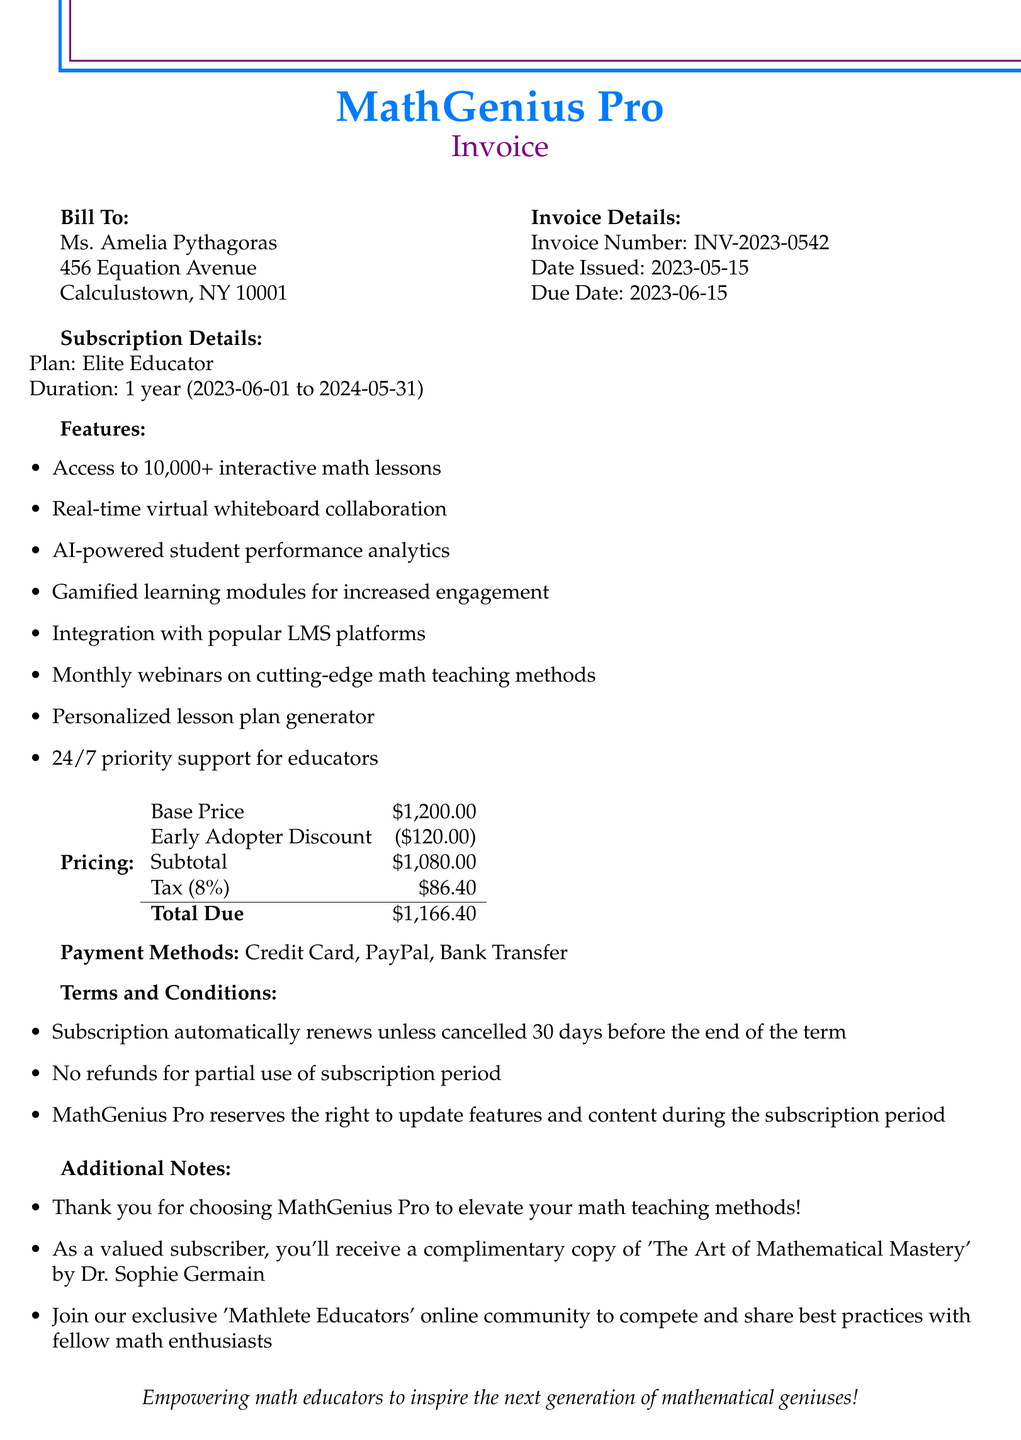What is the invoice number? The invoice number is a unique identifier for the transaction, found in the document.
Answer: INV-2023-0542 What is the due date of the invoice? The due date indicates when the payment must be made, as stated in the document.
Answer: 2023-06-15 What is the annual cost after the discount? The annual cost is listed in the pricing section after applying the early adopter discount.
Answer: 1080.00 What subscription plan is offered? The subscription plan is detailed under the subscription section of the document.
Answer: Elite Educator How many interactive lessons does the platform provide? The number of interactive lessons is mentioned in the features section.
Answer: 10,000+ What is the tax rate applied to the invoice? The tax rate indicates the percentage applied to the subtotal, as stated in the pricing section.
Answer: 0.08 What additional benefit is provided to subscribers? The document mentions an additional benefit offered to subscribers in the additional notes section.
Answer: Complimentary copy of 'The Art of Mathematical Mastery' What payment methods are accepted? The document lists the different payment methods available for this transaction.
Answer: Credit Card, PayPal, Bank Transfer What is stated about the subscription renewal? This information details the automatic renewal policy found in the terms and conditions section.
Answer: Automatically renews unless cancelled 30 days before the end of the term 